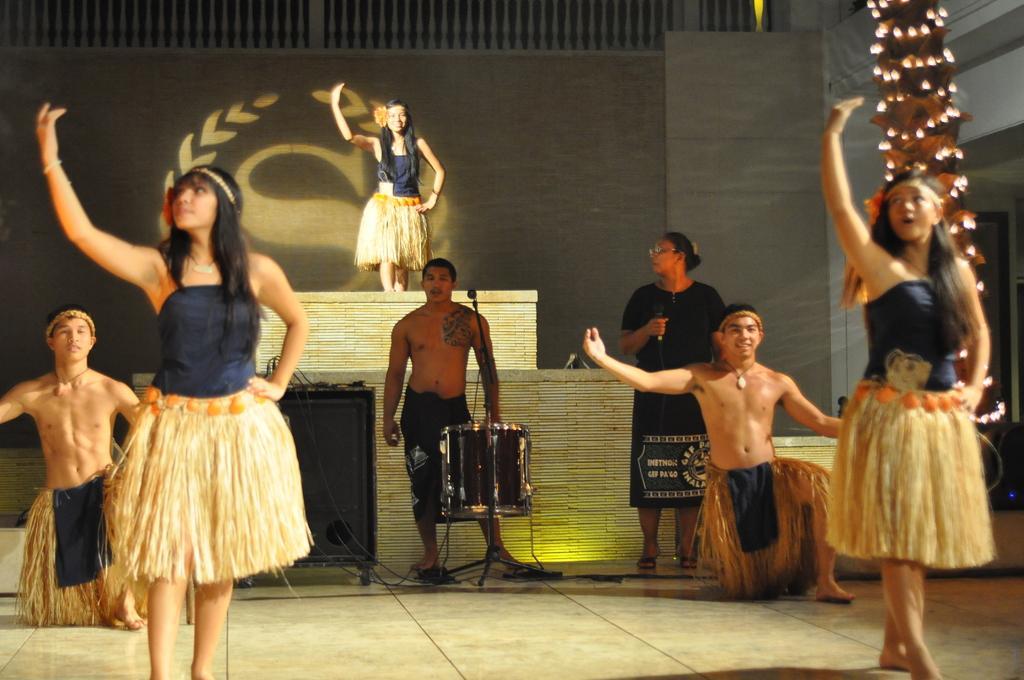In one or two sentences, can you explain what this image depicts? In the image there are three ladies and three men with costumes. There is a man standing in front of him there is a mic and also there is an instrument. Beside him there is a lady standing and holding a mic. There is a speaker and also there is a tree with lights. In the background there is a wall with logo. At the top of the image there is railing. 